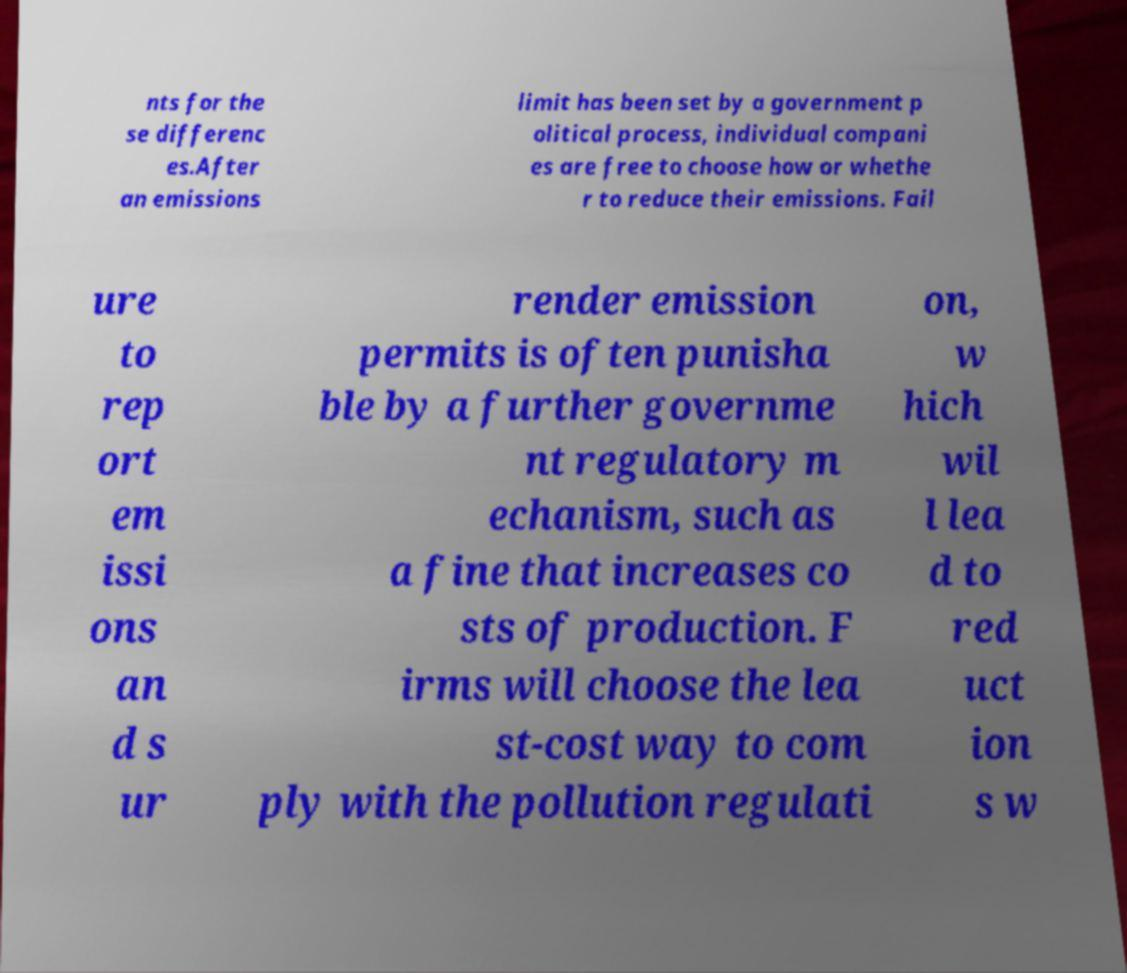There's text embedded in this image that I need extracted. Can you transcribe it verbatim? nts for the se differenc es.After an emissions limit has been set by a government p olitical process, individual compani es are free to choose how or whethe r to reduce their emissions. Fail ure to rep ort em issi ons an d s ur render emission permits is often punisha ble by a further governme nt regulatory m echanism, such as a fine that increases co sts of production. F irms will choose the lea st-cost way to com ply with the pollution regulati on, w hich wil l lea d to red uct ion s w 